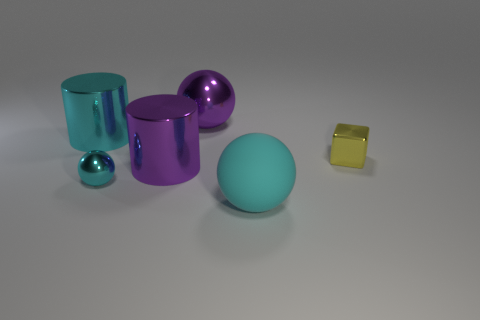How do the different colors of the objects in the image affect the mood or atmosphere depicted? The varied colors of the objects create a vibrant and dynamic visual aesthetic. The cool cyan tone has a calming effect, while the contrasting purple adds a sense of depth and complexity. The inclusion of a reflective yellow cube adds a hint of warmth that balances the composition, resulting in a harmonious and visually appealing scene. 